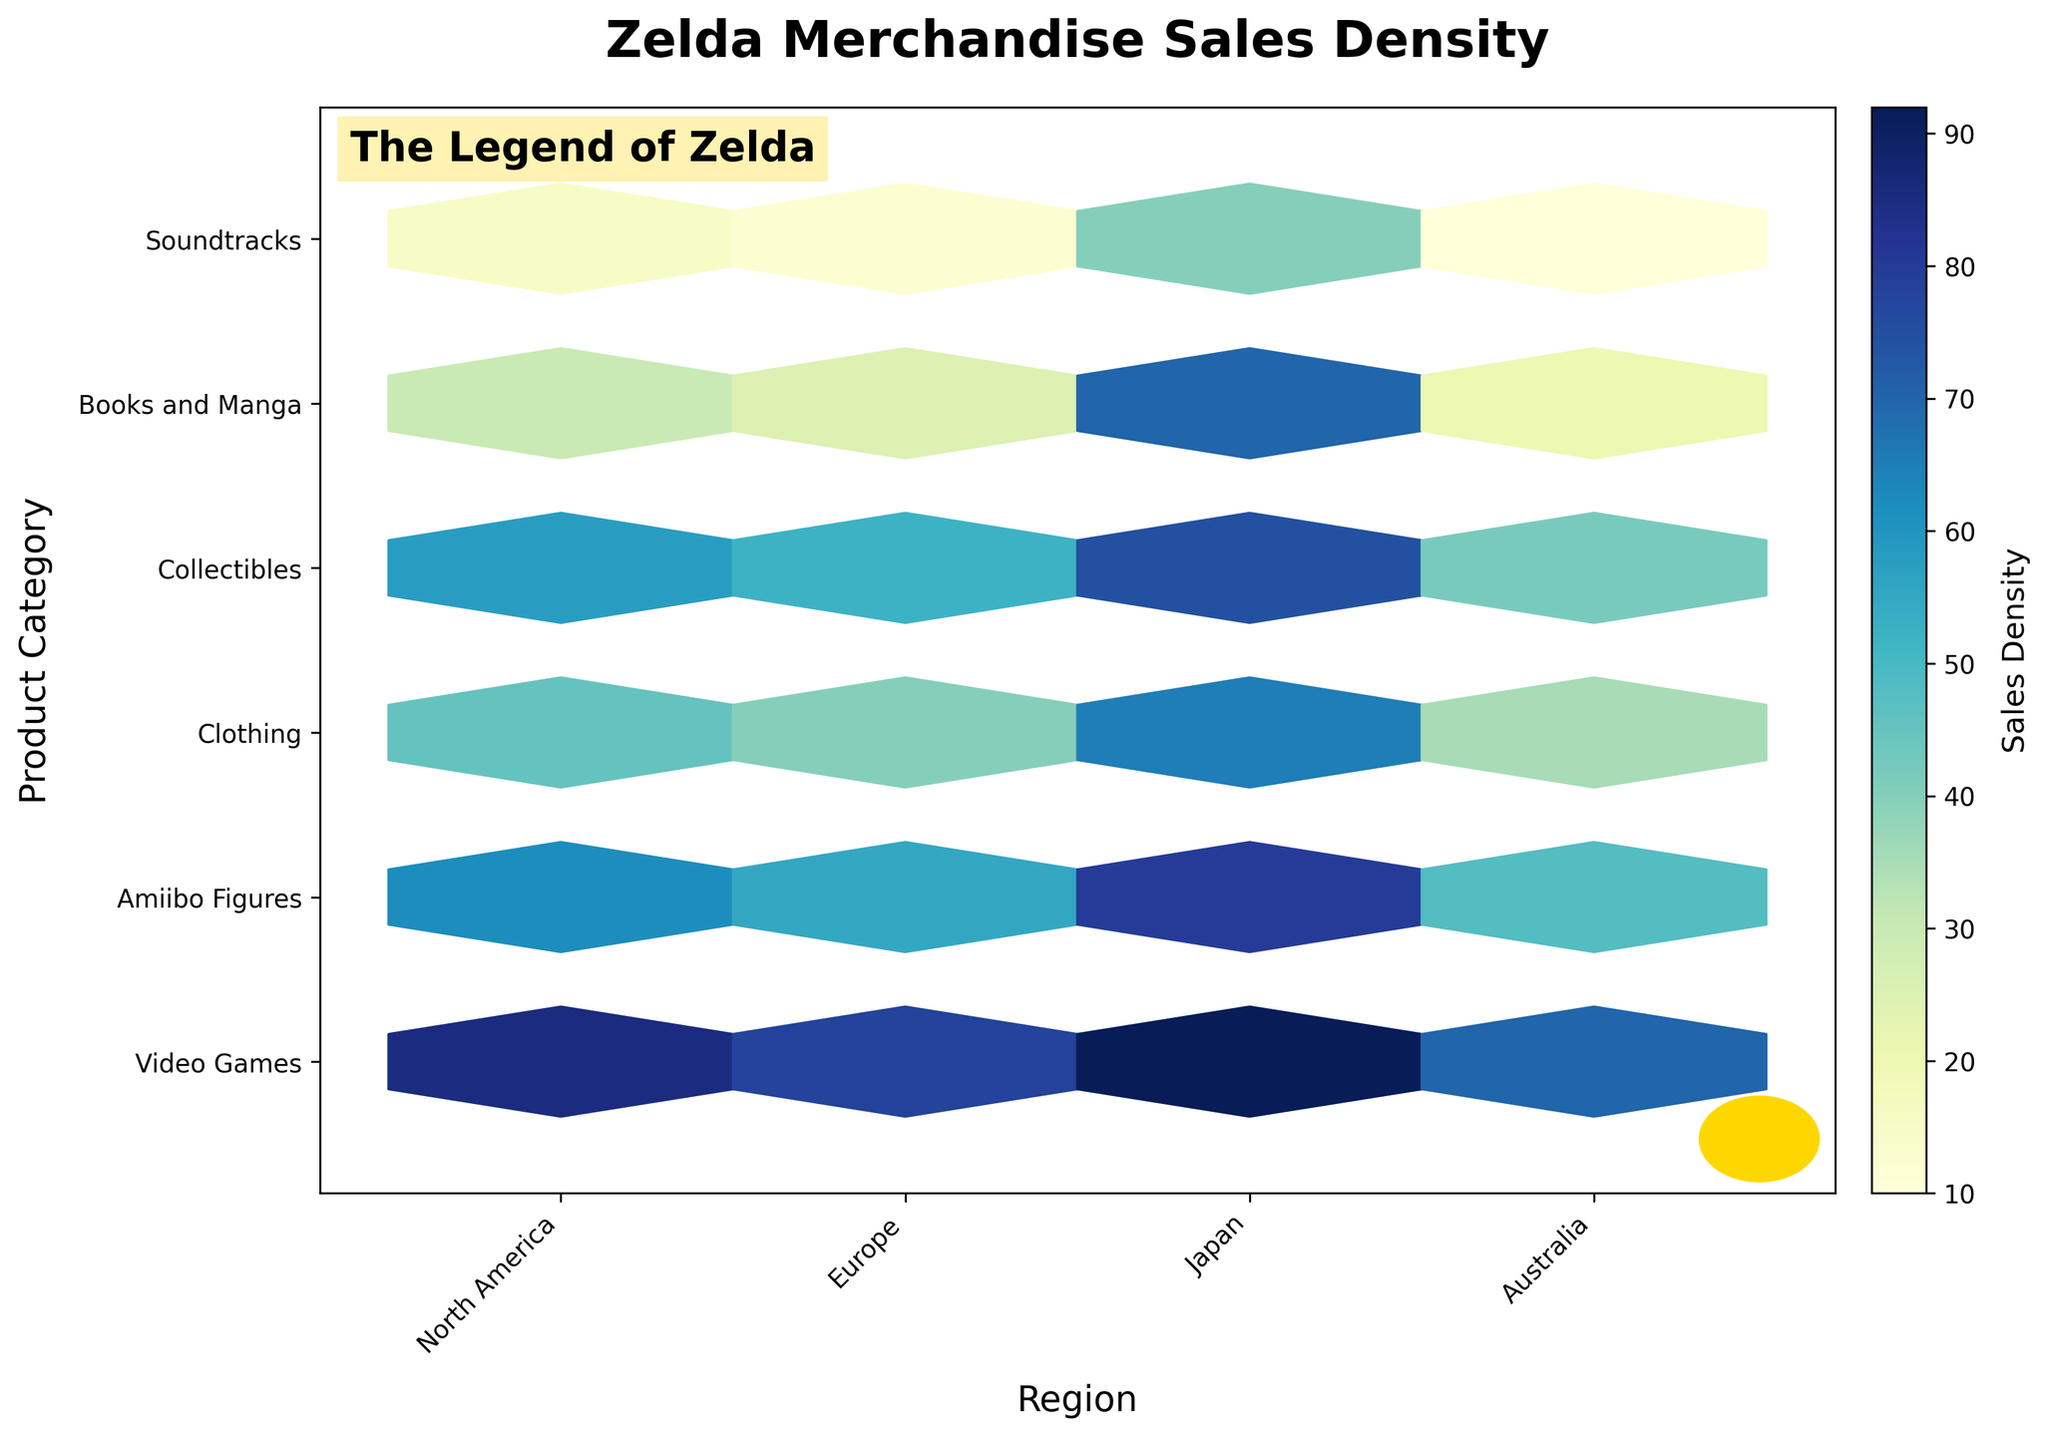What is the title of the hexbin plot? The title of the hexbin plot is typically displayed at the top center of the plot. In this case, it is "Zelda Merchandise Sales Density", which is indicated prominently to give viewers insight into what the plot is about.
Answer: Zelda Merchandise Sales Density Which region corresponds to the highest density of Video Games sales? To find the highest density of Video Games sales, look at the hexbin color intensity for the 'Video Games' category along the 'Region' axis. The darkest color, representing the highest density, is in the 'Japan' region.
Answer: Japan How many product categories are displayed on the y-axis? The y-axis represents different product categories. Counting the labeled categories, we see 'Video Games', 'Amiibo Figures', 'Clothing', 'Collectibles', 'Books and Manga', and 'Soundtracks', totaling 6 categories.
Answer: 6 What region has the lowest sales density for Soundtracks? By examining the lightest color intensity for the 'Soundtracks' category on the y-axis, the 'Australia' region has the lowest sales density.
Answer: Australia Which product category in Europe has a higher sales density: Collectibles or Soundtracks? For Europe, locate the hexagons corresponding to 'Collectibles' and 'Soundtracks'. The hexbin for 'Collectibles' has a darker color compared to 'Soundtracks', indicating higher sales density.
Answer: Collectibles In which category does North America have a lower sales density compared to Japan? Compare sales densities for North America and Japan across all categories. Notably, categories with darker colors for Japan and lighter for North America indicate lower sales densities in North America. Categories fitting this are 'Video Games', 'Amiibo Figures', 'Clothing', 'Collectibles', 'Books and Manga', and 'Soundtracks'.
Answer: (Any category from the list provided, e.g., Video Games) What is the overall trend in sales density for Books and Manga across regions? Analyze the color intensity pattern for 'Books and Manga' across all regions. 'Japan' has the darkest hexbin, indicating the highest density, followed by 'North America', 'Europe', and 'Australia' decreasing in density respectively.
Answer: Japan > North America > Europe > Australia Which product category has the lowest sales density in all regions? Observe all regions for the lightest color intensity across categories. 'Soundtracks' consistently shows lighter colors, indicating the lowest overall sales density.
Answer: Soundtracks How does the sales density for Amiibo Figures in Australia compare to North America? Compare the hexbin colors for 'Amiibo Figures' between 'Australia' and 'North America'. The lighter color in 'Australia' indicates a lower sales density than 'North America'.
Answer: Lower in Australia 